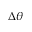Convert formula to latex. <formula><loc_0><loc_0><loc_500><loc_500>\Delta \theta</formula> 